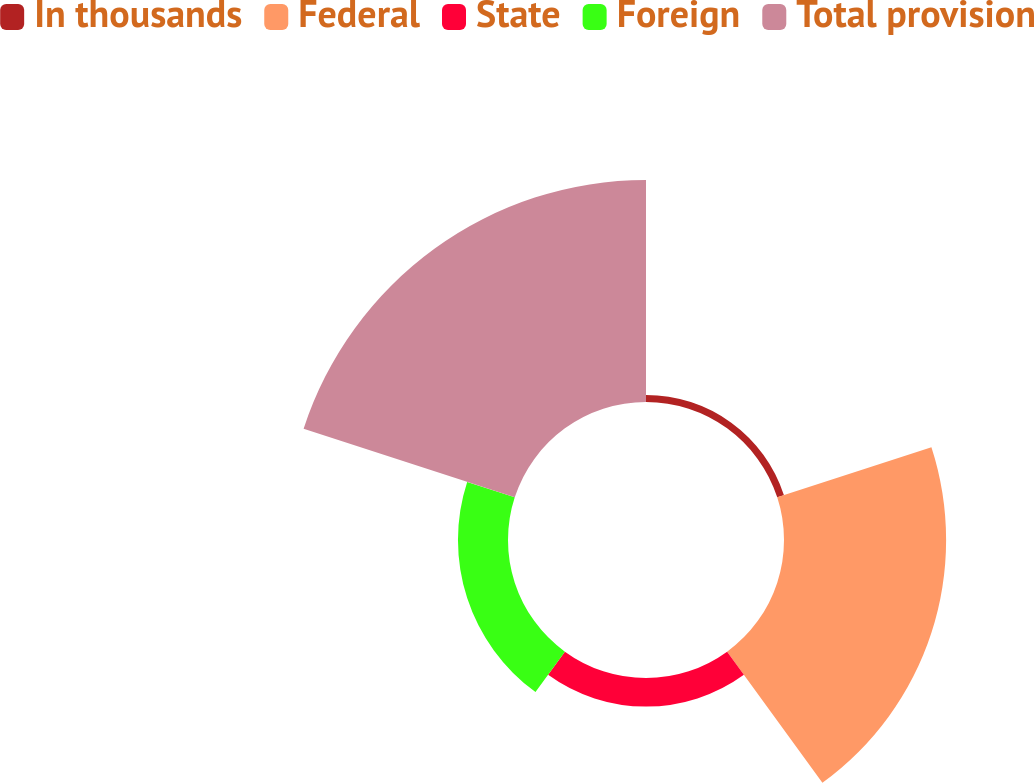<chart> <loc_0><loc_0><loc_500><loc_500><pie_chart><fcel>In thousands<fcel>Federal<fcel>State<fcel>Foreign<fcel>Total provision<nl><fcel>1.5%<fcel>34.51%<fcel>6.08%<fcel>10.65%<fcel>47.26%<nl></chart> 